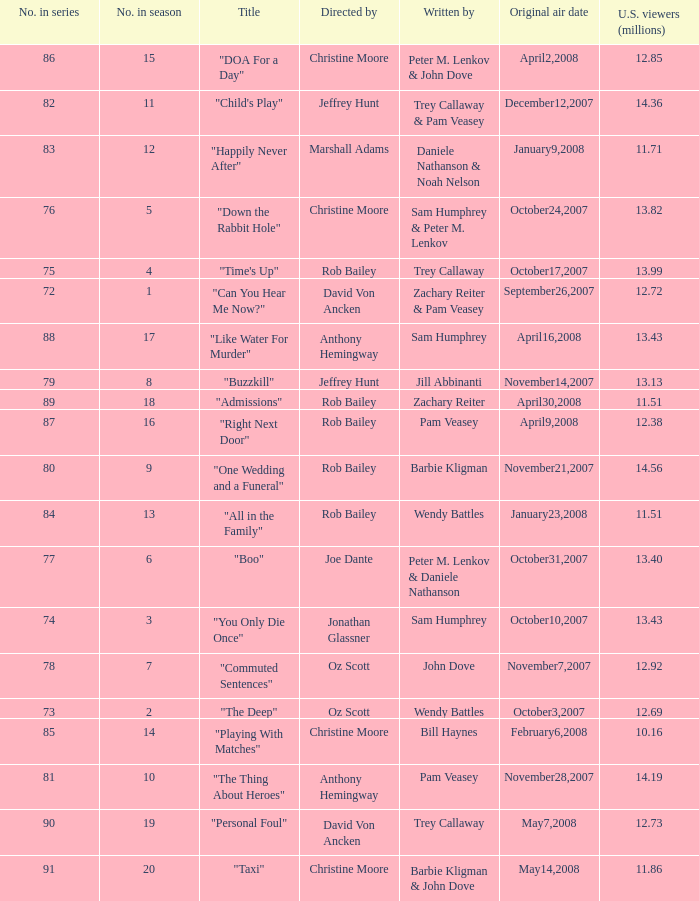How many episodes were viewed by 1 1.0. 